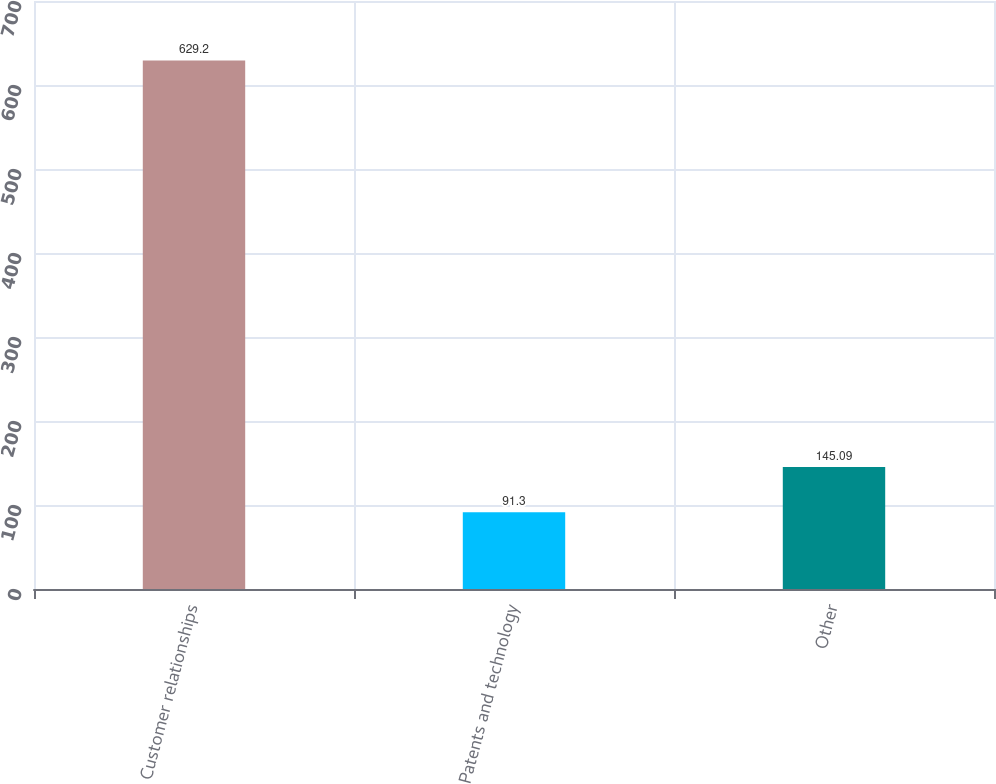Convert chart. <chart><loc_0><loc_0><loc_500><loc_500><bar_chart><fcel>Customer relationships<fcel>Patents and technology<fcel>Other<nl><fcel>629.2<fcel>91.3<fcel>145.09<nl></chart> 